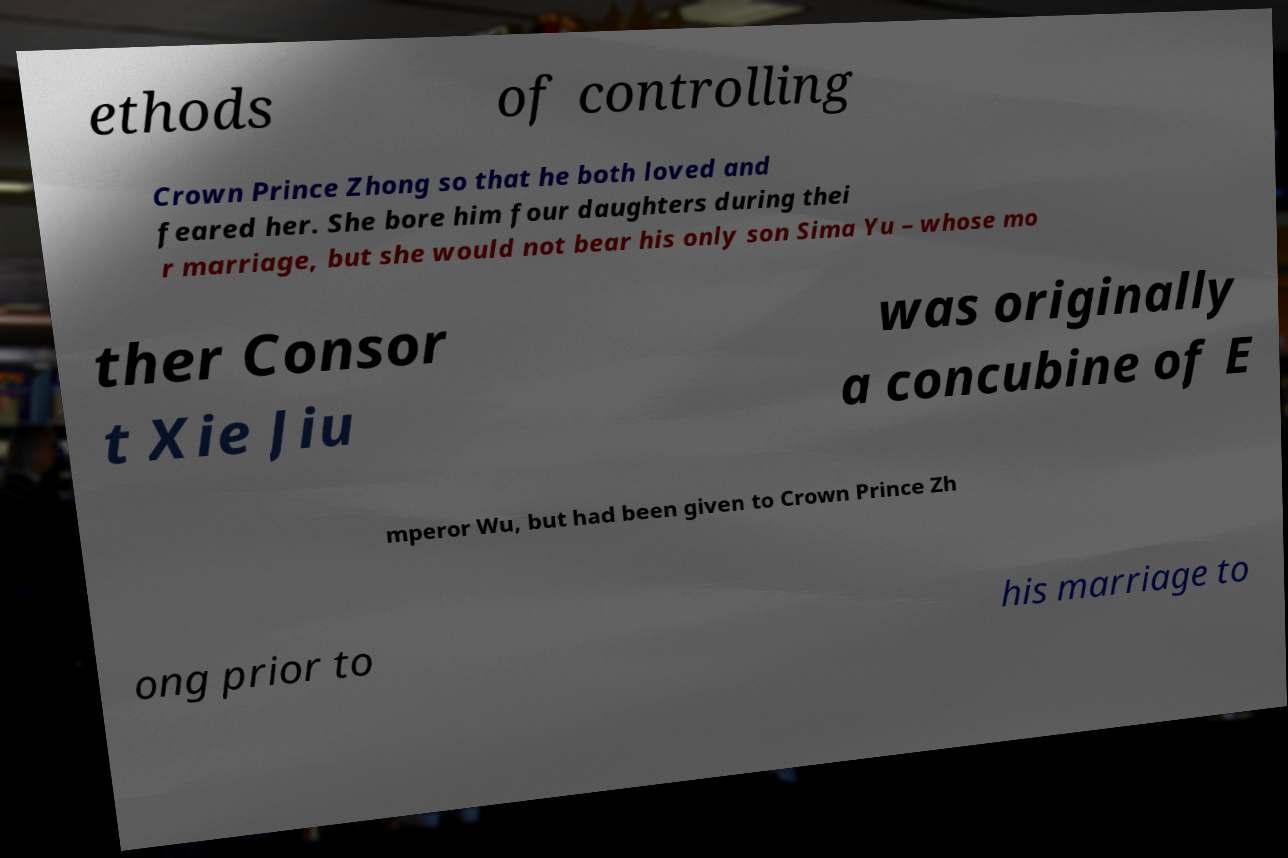Please read and relay the text visible in this image. What does it say? ethods of controlling Crown Prince Zhong so that he both loved and feared her. She bore him four daughters during thei r marriage, but she would not bear his only son Sima Yu – whose mo ther Consor t Xie Jiu was originally a concubine of E mperor Wu, but had been given to Crown Prince Zh ong prior to his marriage to 